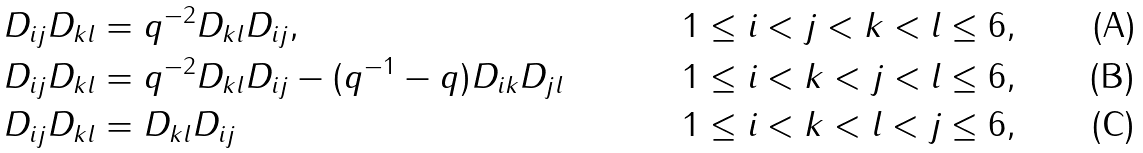<formula> <loc_0><loc_0><loc_500><loc_500>& D _ { i j } D _ { k l } = q ^ { - 2 } D _ { k l } D _ { i j } , & & 1 \leq i < j < k < l \leq 6 , \\ & D _ { i j } D _ { k l } = q ^ { - 2 } D _ { k l } D _ { i j } - ( q ^ { - 1 } - q ) D _ { i k } D _ { j l } & & 1 \leq i < k < j < l \leq 6 , \\ & D _ { i j } D _ { k l } = D _ { k l } D _ { i j } & & 1 \leq i < k < l < j \leq 6 ,</formula> 